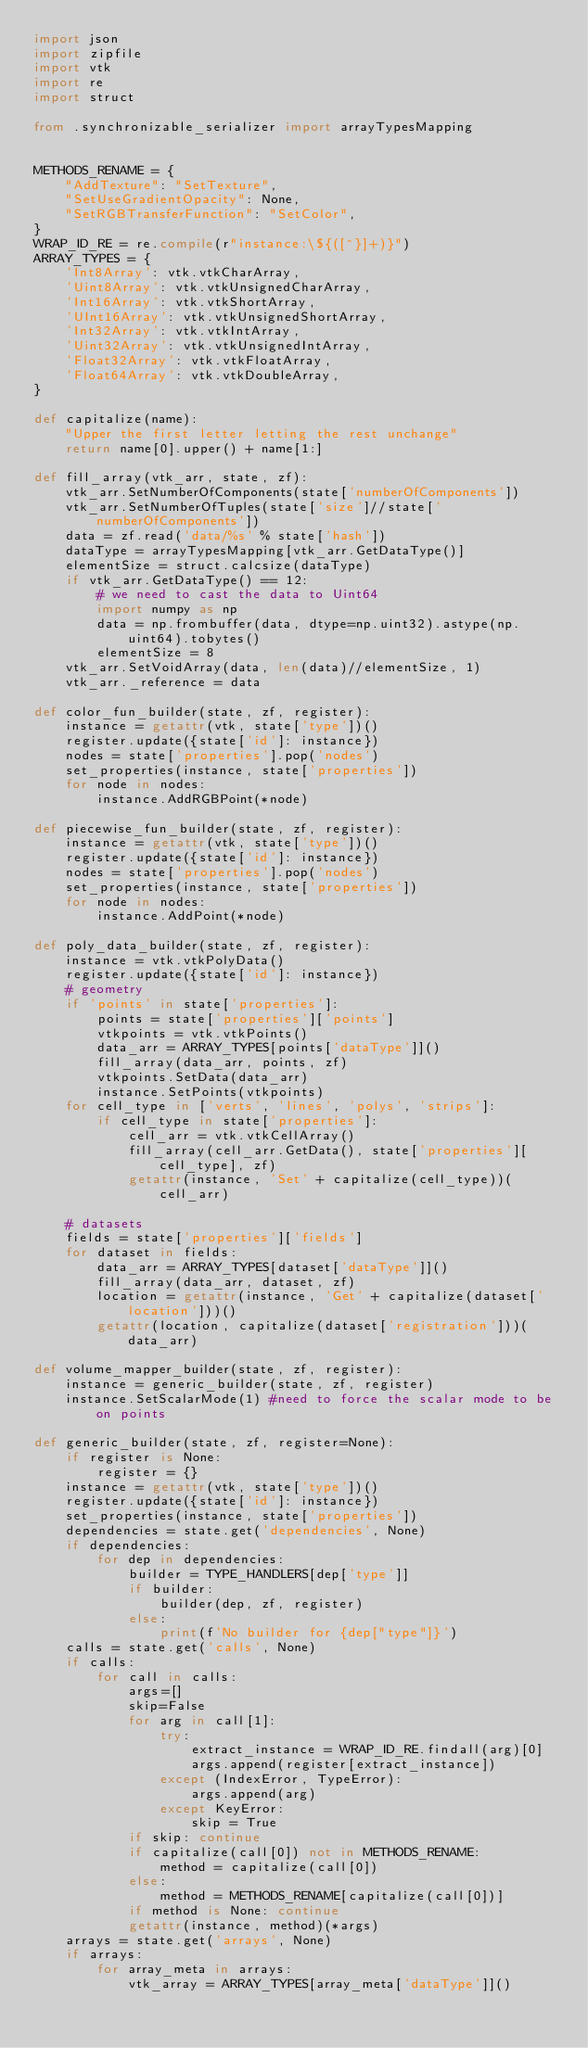Convert code to text. <code><loc_0><loc_0><loc_500><loc_500><_Python_>import json
import zipfile
import vtk
import re
import struct

from .synchronizable_serializer import arrayTypesMapping


METHODS_RENAME = {
    "AddTexture": "SetTexture",
    "SetUseGradientOpacity": None,
    "SetRGBTransferFunction": "SetColor",
}
WRAP_ID_RE = re.compile(r"instance:\${([^}]+)}")
ARRAY_TYPES = {
    'Int8Array': vtk.vtkCharArray,
    'Uint8Array': vtk.vtkUnsignedCharArray,
    'Int16Array': vtk.vtkShortArray,
    'UInt16Array': vtk.vtkUnsignedShortArray,
    'Int32Array': vtk.vtkIntArray,
    'Uint32Array': vtk.vtkUnsignedIntArray,
    'Float32Array': vtk.vtkFloatArray,
    'Float64Array': vtk.vtkDoubleArray,
}

def capitalize(name):
    "Upper the first letter letting the rest unchange"
    return name[0].upper() + name[1:]

def fill_array(vtk_arr, state, zf):
    vtk_arr.SetNumberOfComponents(state['numberOfComponents'])
    vtk_arr.SetNumberOfTuples(state['size']//state['numberOfComponents'])
    data = zf.read('data/%s' % state['hash'])
    dataType = arrayTypesMapping[vtk_arr.GetDataType()]
    elementSize = struct.calcsize(dataType)
    if vtk_arr.GetDataType() == 12:
        # we need to cast the data to Uint64
        import numpy as np
        data = np.frombuffer(data, dtype=np.uint32).astype(np.uint64).tobytes()
        elementSize = 8
    vtk_arr.SetVoidArray(data, len(data)//elementSize, 1)
    vtk_arr._reference = data

def color_fun_builder(state, zf, register):
    instance = getattr(vtk, state['type'])()
    register.update({state['id']: instance})
    nodes = state['properties'].pop('nodes')
    set_properties(instance, state['properties'])
    for node in nodes:
        instance.AddRGBPoint(*node)

def piecewise_fun_builder(state, zf, register):
    instance = getattr(vtk, state['type'])()
    register.update({state['id']: instance})
    nodes = state['properties'].pop('nodes')
    set_properties(instance, state['properties'])
    for node in nodes:
        instance.AddPoint(*node)

def poly_data_builder(state, zf, register):
    instance = vtk.vtkPolyData()
    register.update({state['id']: instance})
    # geometry
    if 'points' in state['properties']:
        points = state['properties']['points']
        vtkpoints = vtk.vtkPoints()
        data_arr = ARRAY_TYPES[points['dataType']]()
        fill_array(data_arr, points, zf)
        vtkpoints.SetData(data_arr)
        instance.SetPoints(vtkpoints)
    for cell_type in ['verts', 'lines', 'polys', 'strips']:
        if cell_type in state['properties']:
            cell_arr = vtk.vtkCellArray()
            fill_array(cell_arr.GetData(), state['properties'][cell_type], zf)
            getattr(instance, 'Set' + capitalize(cell_type))(cell_arr)
    
    # datasets
    fields = state['properties']['fields']
    for dataset in fields:
        data_arr = ARRAY_TYPES[dataset['dataType']]()
        fill_array(data_arr, dataset, zf)
        location = getattr(instance, 'Get' + capitalize(dataset['location']))()
        getattr(location, capitalize(dataset['registration']))(data_arr)

def volume_mapper_builder(state, zf, register):
    instance = generic_builder(state, zf, register)
    instance.SetScalarMode(1) #need to force the scalar mode to be on points

def generic_builder(state, zf, register=None):
    if register is None:
        register = {}
    instance = getattr(vtk, state['type'])()
    register.update({state['id']: instance})
    set_properties(instance, state['properties'])
    dependencies = state.get('dependencies', None)
    if dependencies:
        for dep in dependencies:
            builder = TYPE_HANDLERS[dep['type']]
            if builder:
                builder(dep, zf, register)
            else:
                print(f'No builder for {dep["type"]}')
    calls = state.get('calls', None)
    if calls:
        for call in calls:
            args=[]
            skip=False
            for arg in call[1]:
                try:
                    extract_instance = WRAP_ID_RE.findall(arg)[0]
                    args.append(register[extract_instance])
                except (IndexError, TypeError):
                    args.append(arg)
                except KeyError:
                    skip = True
            if skip: continue
            if capitalize(call[0]) not in METHODS_RENAME:
                method = capitalize(call[0])
            else:
                method = METHODS_RENAME[capitalize(call[0])]
            if method is None: continue
            getattr(instance, method)(*args)
    arrays = state.get('arrays', None)
    if arrays:
        for array_meta in arrays:
            vtk_array = ARRAY_TYPES[array_meta['dataType']]()</code> 